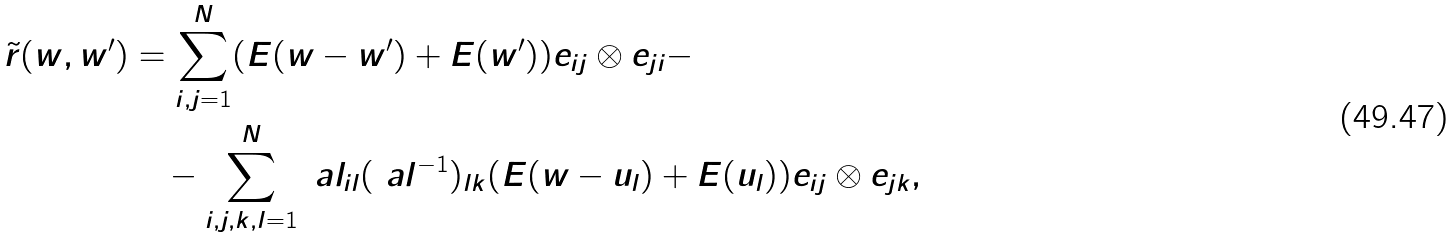<formula> <loc_0><loc_0><loc_500><loc_500>\tilde { r } ( w , w ^ { \prime } ) & = \sum _ { i , j = 1 } ^ { N } ( E ( w - w ^ { \prime } ) + E ( w ^ { \prime } ) ) e _ { i j } \otimes e _ { j i } - \\ & \quad - \sum _ { i , j , k , l = 1 } ^ { N } \ a l _ { i l } ( \ a l ^ { - 1 } ) _ { l k } ( E ( w - u _ { l } ) + E ( u _ { l } ) ) e _ { i j } \otimes e _ { j k } ,</formula> 